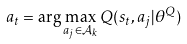Convert formula to latex. <formula><loc_0><loc_0><loc_500><loc_500>a _ { t } = \arg \max _ { a _ { j } \in \mathcal { A } _ { k } } Q ( s _ { t } , a _ { j } | \theta ^ { Q } )</formula> 